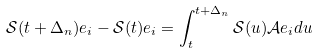Convert formula to latex. <formula><loc_0><loc_0><loc_500><loc_500>\mathcal { S } ( t + \Delta _ { n } ) e _ { i } - \mathcal { S } ( t ) e _ { i } = \int _ { t } ^ { t + \Delta _ { n } } \mathcal { S } ( u ) \mathcal { A } e _ { i } d u</formula> 